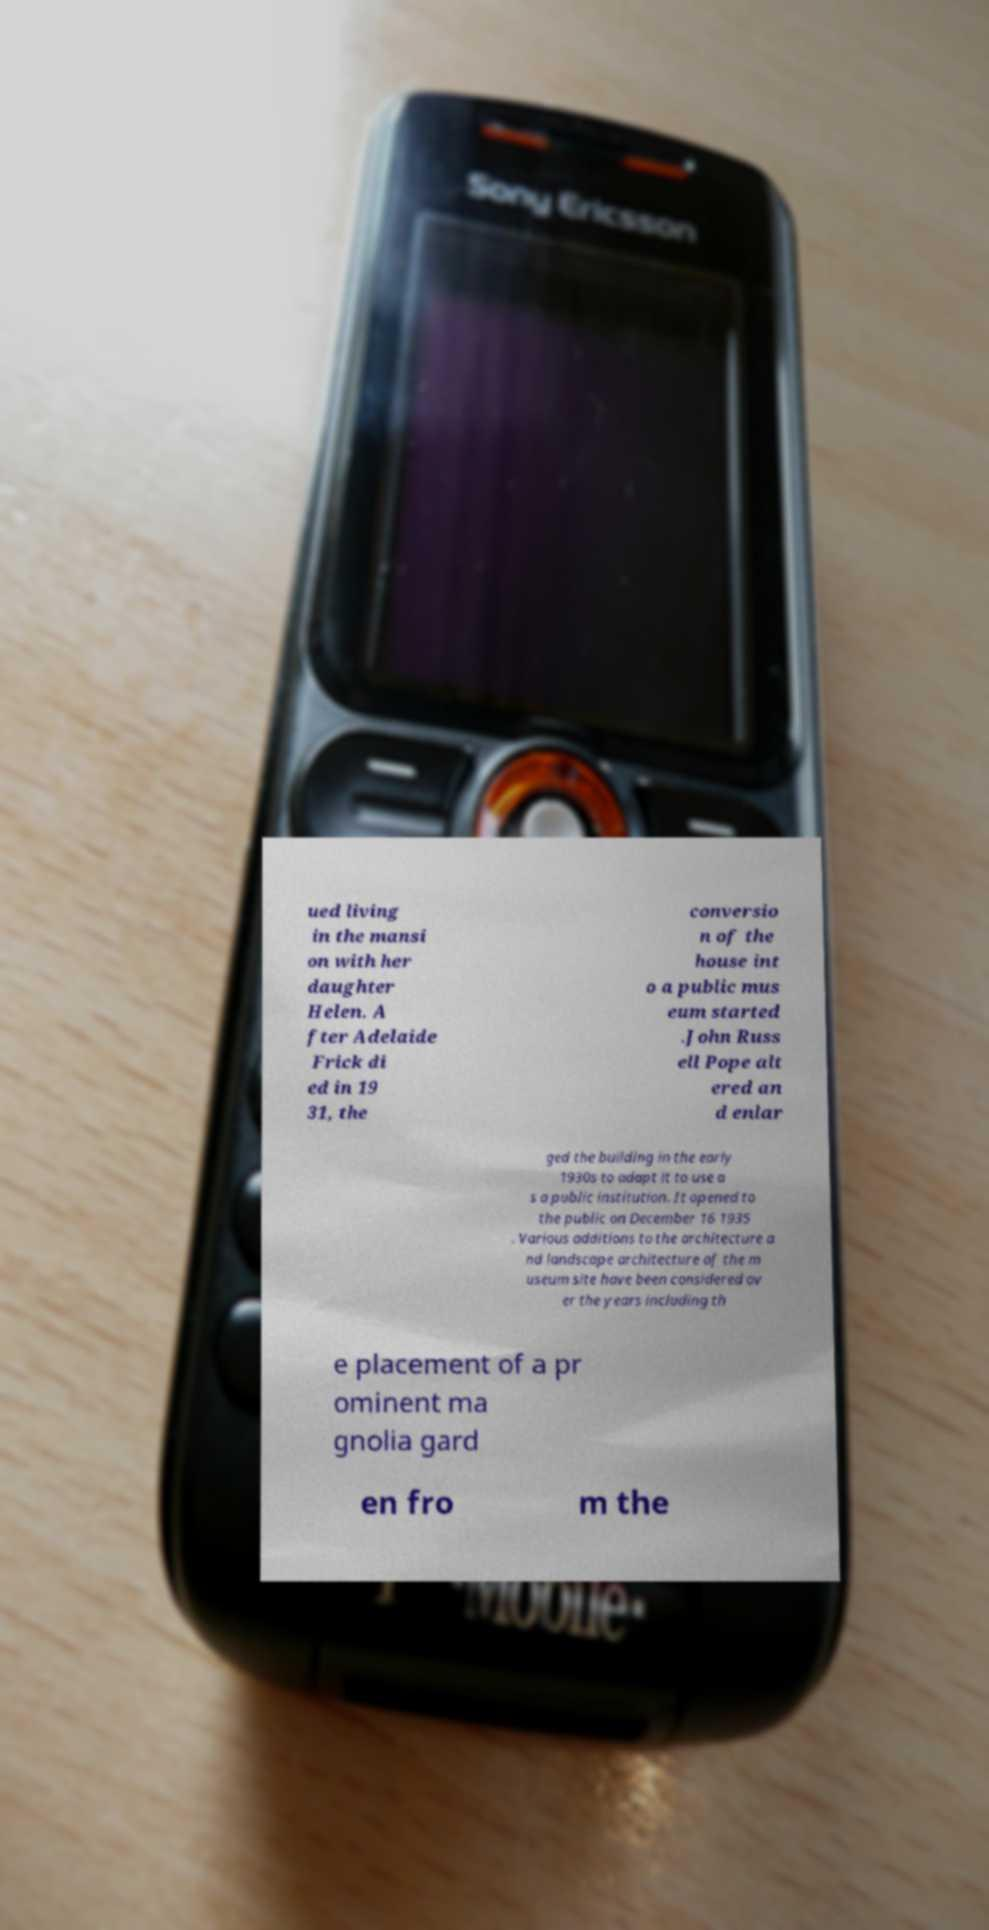I need the written content from this picture converted into text. Can you do that? ued living in the mansi on with her daughter Helen. A fter Adelaide Frick di ed in 19 31, the conversio n of the house int o a public mus eum started .John Russ ell Pope alt ered an d enlar ged the building in the early 1930s to adapt it to use a s a public institution. It opened to the public on December 16 1935 . Various additions to the architecture a nd landscape architecture of the m useum site have been considered ov er the years including th e placement of a pr ominent ma gnolia gard en fro m the 